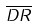Convert formula to latex. <formula><loc_0><loc_0><loc_500><loc_500>\overline { D R }</formula> 